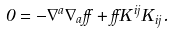Convert formula to latex. <formula><loc_0><loc_0><loc_500><loc_500>0 = - \nabla ^ { a } \nabla _ { a } \alpha + \alpha K ^ { i j } K _ { i j } .</formula> 